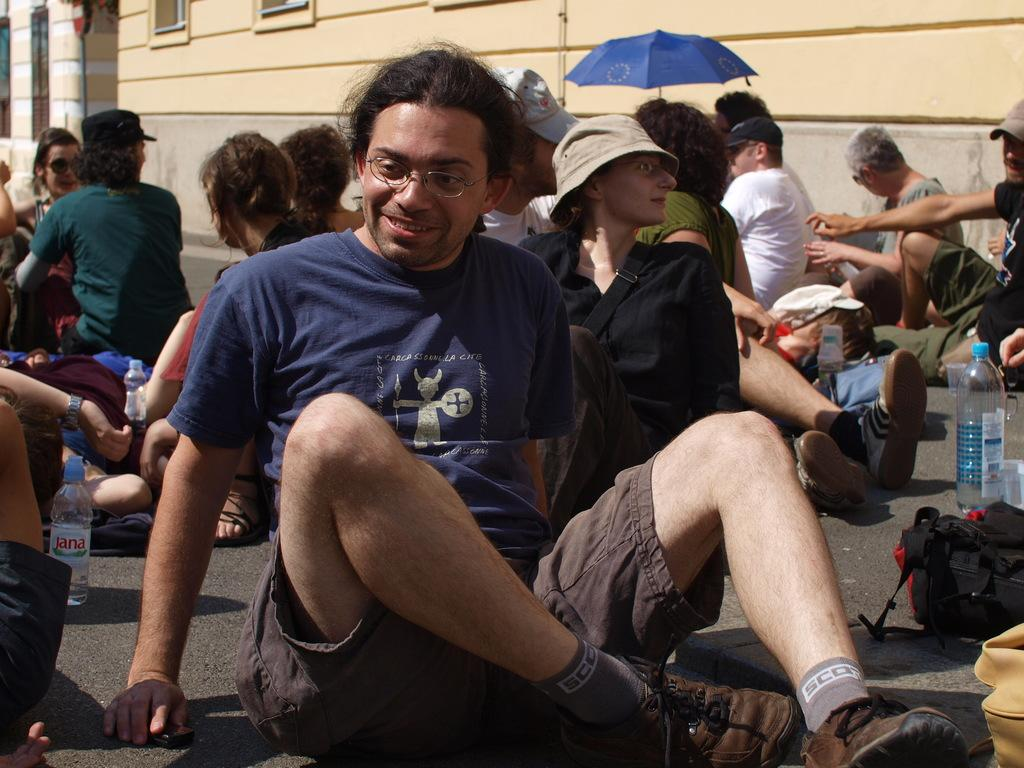What are the people in the image doing? There are many people sitting on the road in the image. What is the weather like in the image? The day appears to be sunny. What can be seen in the background of the image? There are buildings in the background of the image. Can you describe the clothing of the man in the front? The man in the front is wearing a violet t-shirt and brown shorts. What causes the man in the front to laugh in the image? There is no indication in the image that the man is laughing, nor is there any information about what might cause him to laugh. 